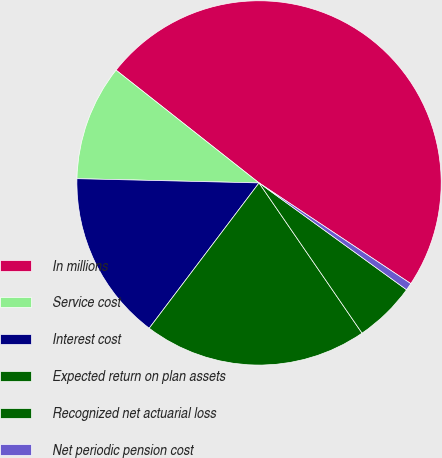Convert chart to OTSL. <chart><loc_0><loc_0><loc_500><loc_500><pie_chart><fcel>In millions<fcel>Service cost<fcel>Interest cost<fcel>Expected return on plan assets<fcel>Recognized net actuarial loss<fcel>Net periodic pension cost<nl><fcel>48.7%<fcel>10.26%<fcel>15.07%<fcel>19.87%<fcel>5.46%<fcel>0.65%<nl></chart> 